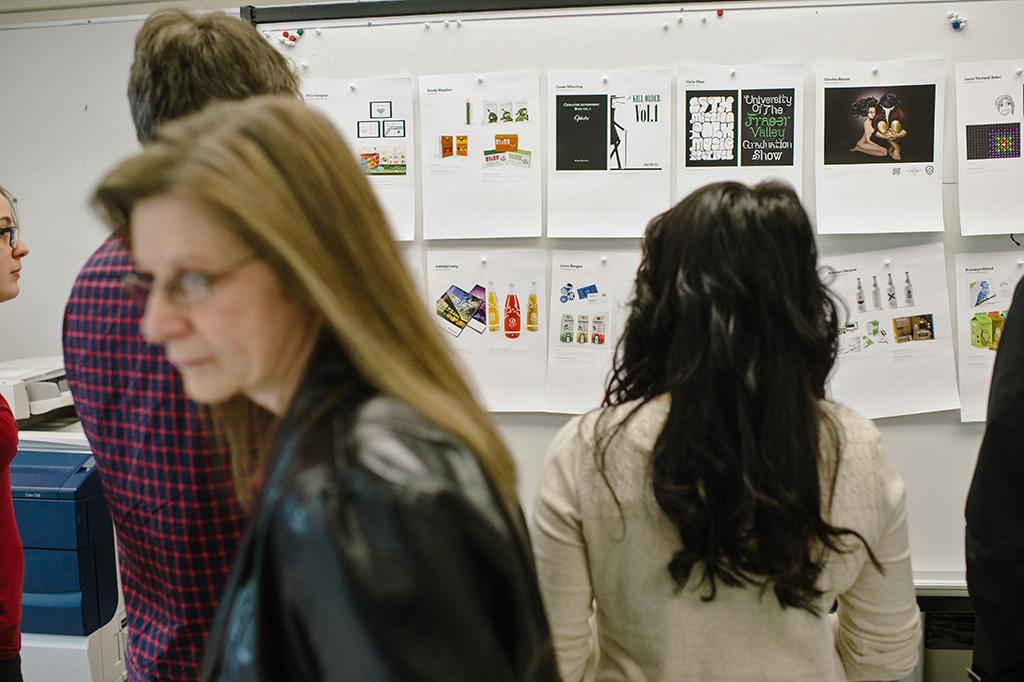Who is the main subject in the image? There is a woman in the image. Can you describe the people behind the woman? There are three people behind the woman, and they are looking at posters on a board. What is located beside the board? There is a xerox machine beside the board. What type of pies are being served for dinner in the image? There is no mention of dinner or pies in the image; it features a woman and three people looking at posters on a board. 